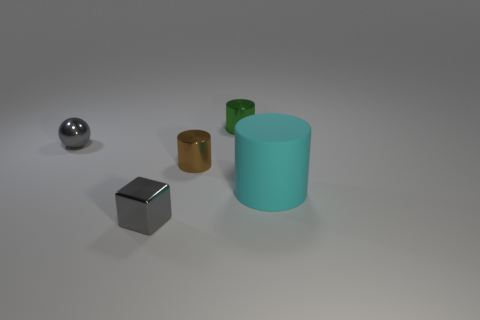Subtract all green cylinders. Subtract all blue blocks. How many cylinders are left? 2 Add 5 big cyan things. How many objects exist? 10 Subtract all balls. How many objects are left? 4 Subtract all large cyan spheres. Subtract all gray shiny cubes. How many objects are left? 4 Add 2 small metal cubes. How many small metal cubes are left? 3 Add 4 brown shiny objects. How many brown shiny objects exist? 5 Subtract 0 purple balls. How many objects are left? 5 